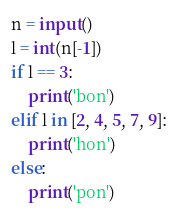Convert code to text. <code><loc_0><loc_0><loc_500><loc_500><_Python_>n = input()
l = int(n[-1])
if l == 3:
    print('bon')
elif l in [2, 4, 5, 7, 9]:
    print('hon')
else:
    print('pon')
</code> 